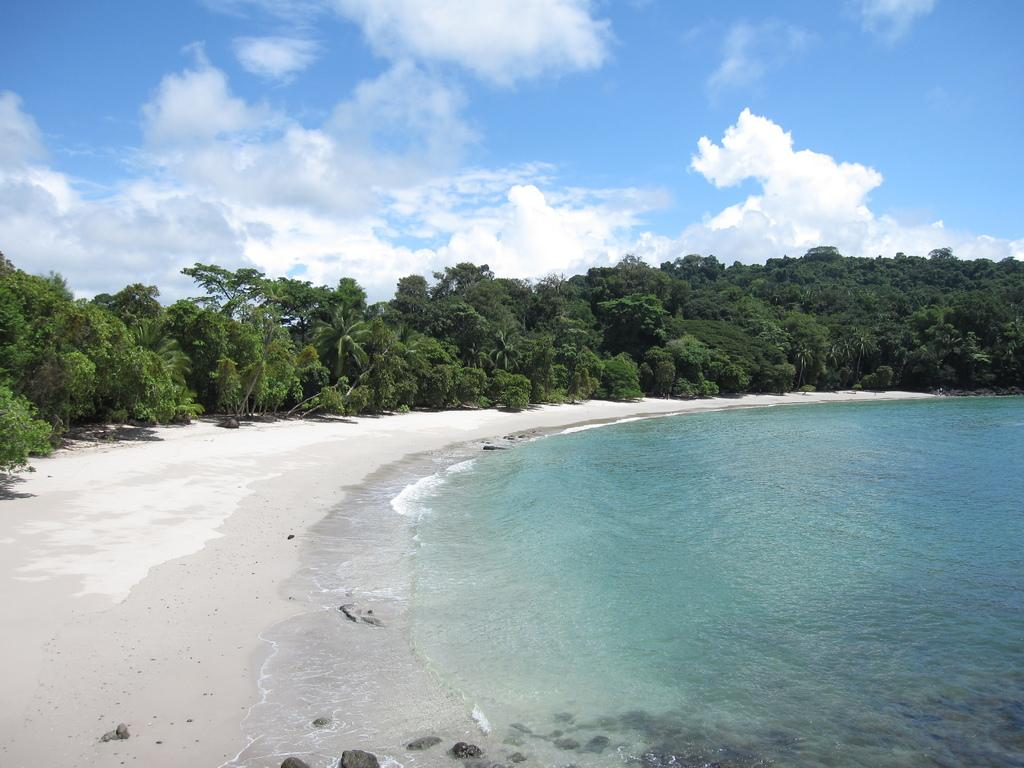What type of natural body of water is visible in the image? There is a sea in the image. What type of vegetation can be seen around the sea in the image? There are trees around the sea in the image. What type of connection can be seen between the trees in the image? There is no specific connection between the trees mentioned in the image. They are simply trees surrounding the sea. 